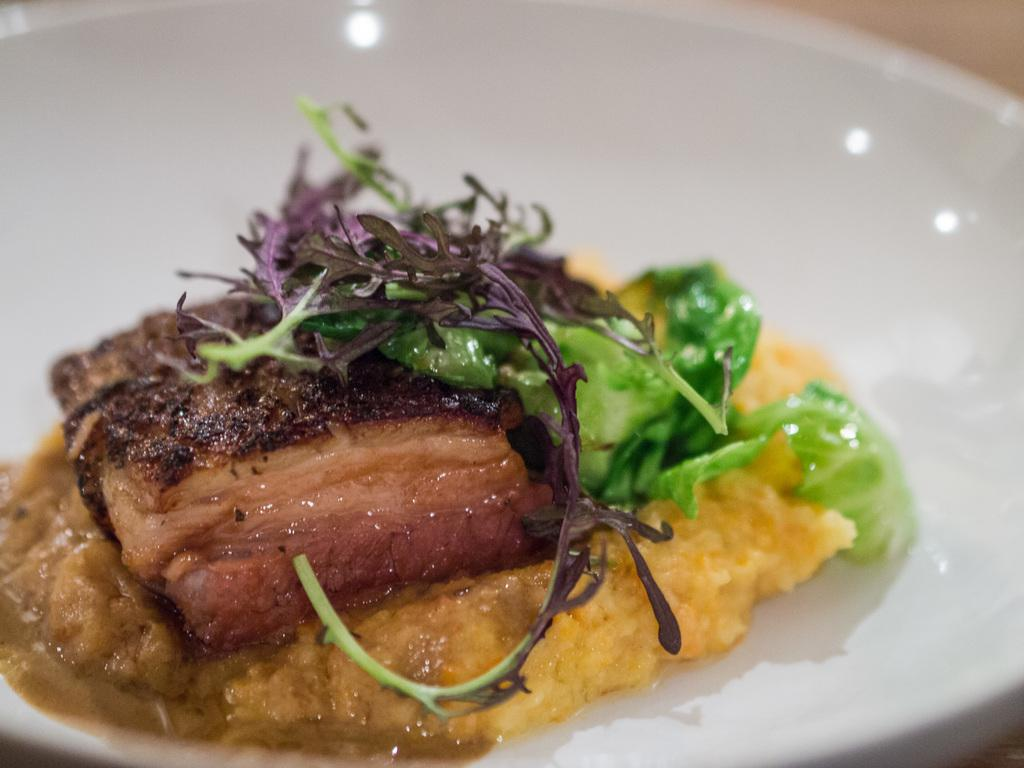What is the main subject of the image? There is a food item in the image. How is the food item presented in the image? The food item is on a white plate. What type of station can be seen in the background of the image? There is no station present in the image; it only features a food item on a white plate. How does the food item affect the breath of the person looking at the image? The image does not show any person, so it cannot be determined how the food item might affect their breath. 